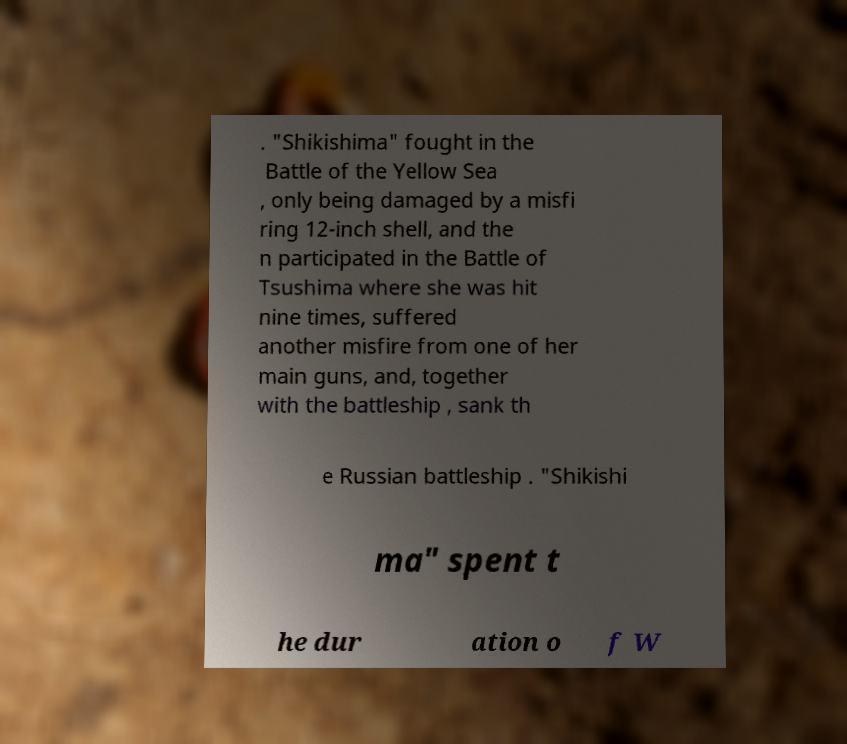Can you accurately transcribe the text from the provided image for me? . "Shikishima" fought in the Battle of the Yellow Sea , only being damaged by a misfi ring 12-inch shell, and the n participated in the Battle of Tsushima where she was hit nine times, suffered another misfire from one of her main guns, and, together with the battleship , sank th e Russian battleship . "Shikishi ma" spent t he dur ation o f W 